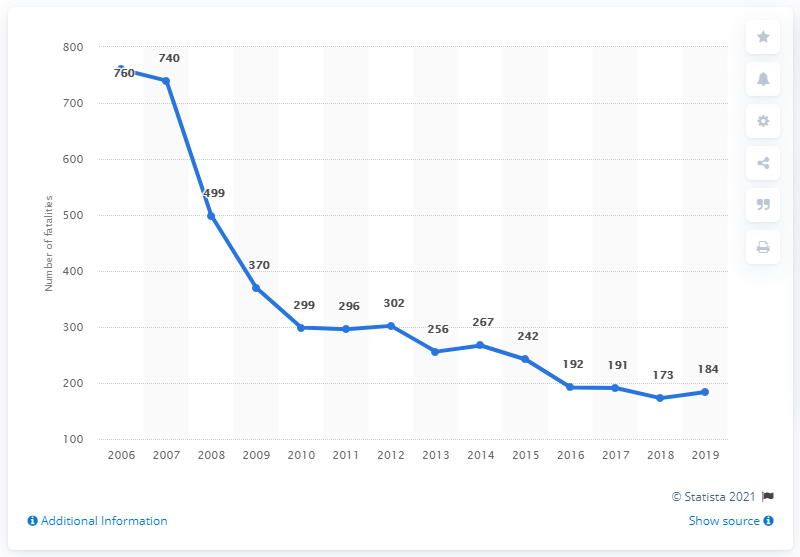Specify some key components in this picture. In 2006, the highest number of road fatalities occurred. Between 2006 and 2019, a total of 760 road fatalities occurred in Lithuania. In 2018, Lithuania had a total of 184 road traffic fatalities. 